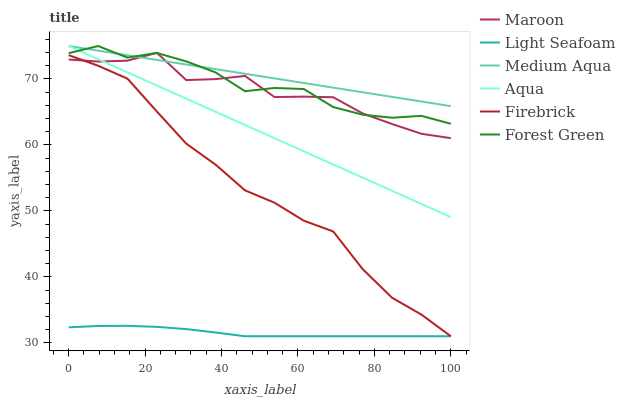Does Aqua have the minimum area under the curve?
Answer yes or no. No. Does Aqua have the maximum area under the curve?
Answer yes or no. No. Is Maroon the smoothest?
Answer yes or no. No. Is Aqua the roughest?
Answer yes or no. No. Does Aqua have the lowest value?
Answer yes or no. No. Does Maroon have the highest value?
Answer yes or no. No. Is Light Seafoam less than Medium Aqua?
Answer yes or no. Yes. Is Medium Aqua greater than Firebrick?
Answer yes or no. Yes. Does Light Seafoam intersect Medium Aqua?
Answer yes or no. No. 